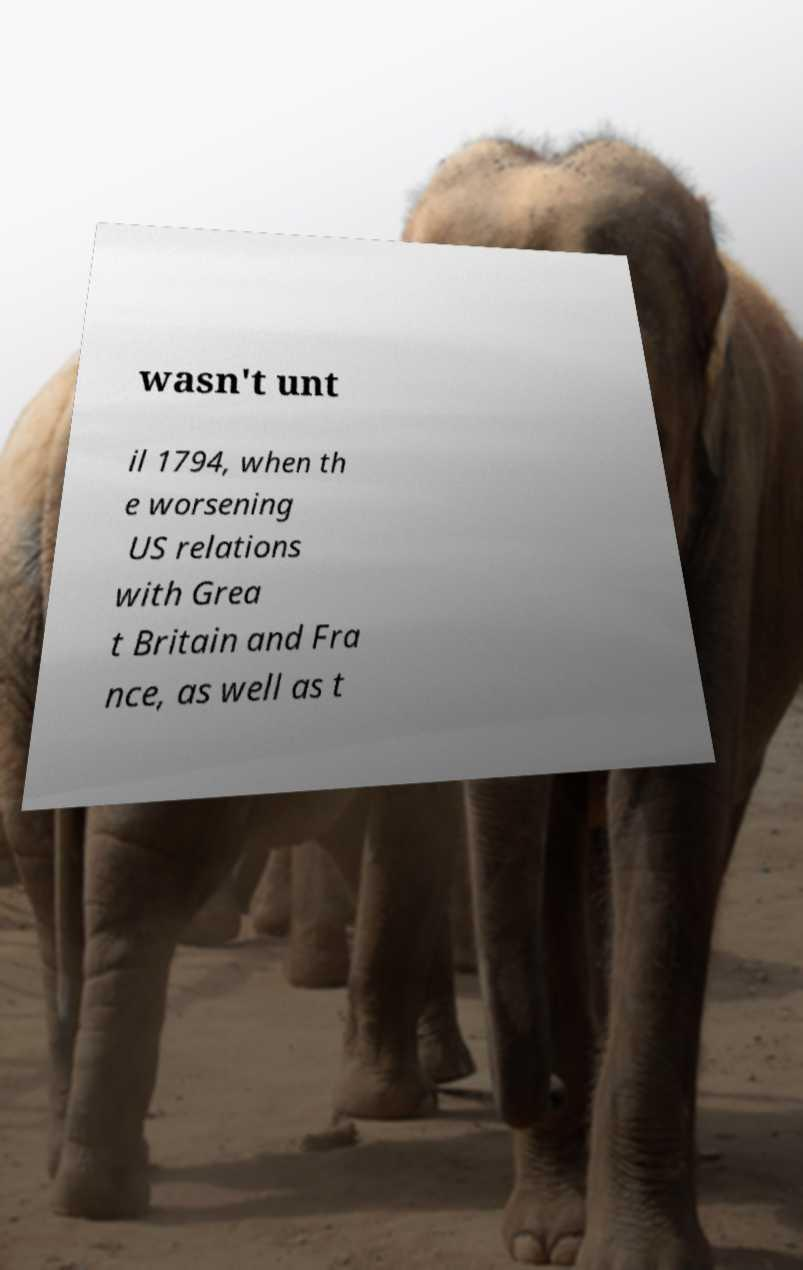There's text embedded in this image that I need extracted. Can you transcribe it verbatim? wasn't unt il 1794, when th e worsening US relations with Grea t Britain and Fra nce, as well as t 